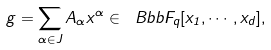<formula> <loc_0><loc_0><loc_500><loc_500>g = \sum _ { \alpha \in J } A _ { \alpha } x ^ { \alpha } \in \ B b b { F } _ { q } [ x _ { 1 } , \cdots , x _ { d } ] ,</formula> 